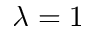Convert formula to latex. <formula><loc_0><loc_0><loc_500><loc_500>\lambda = 1</formula> 